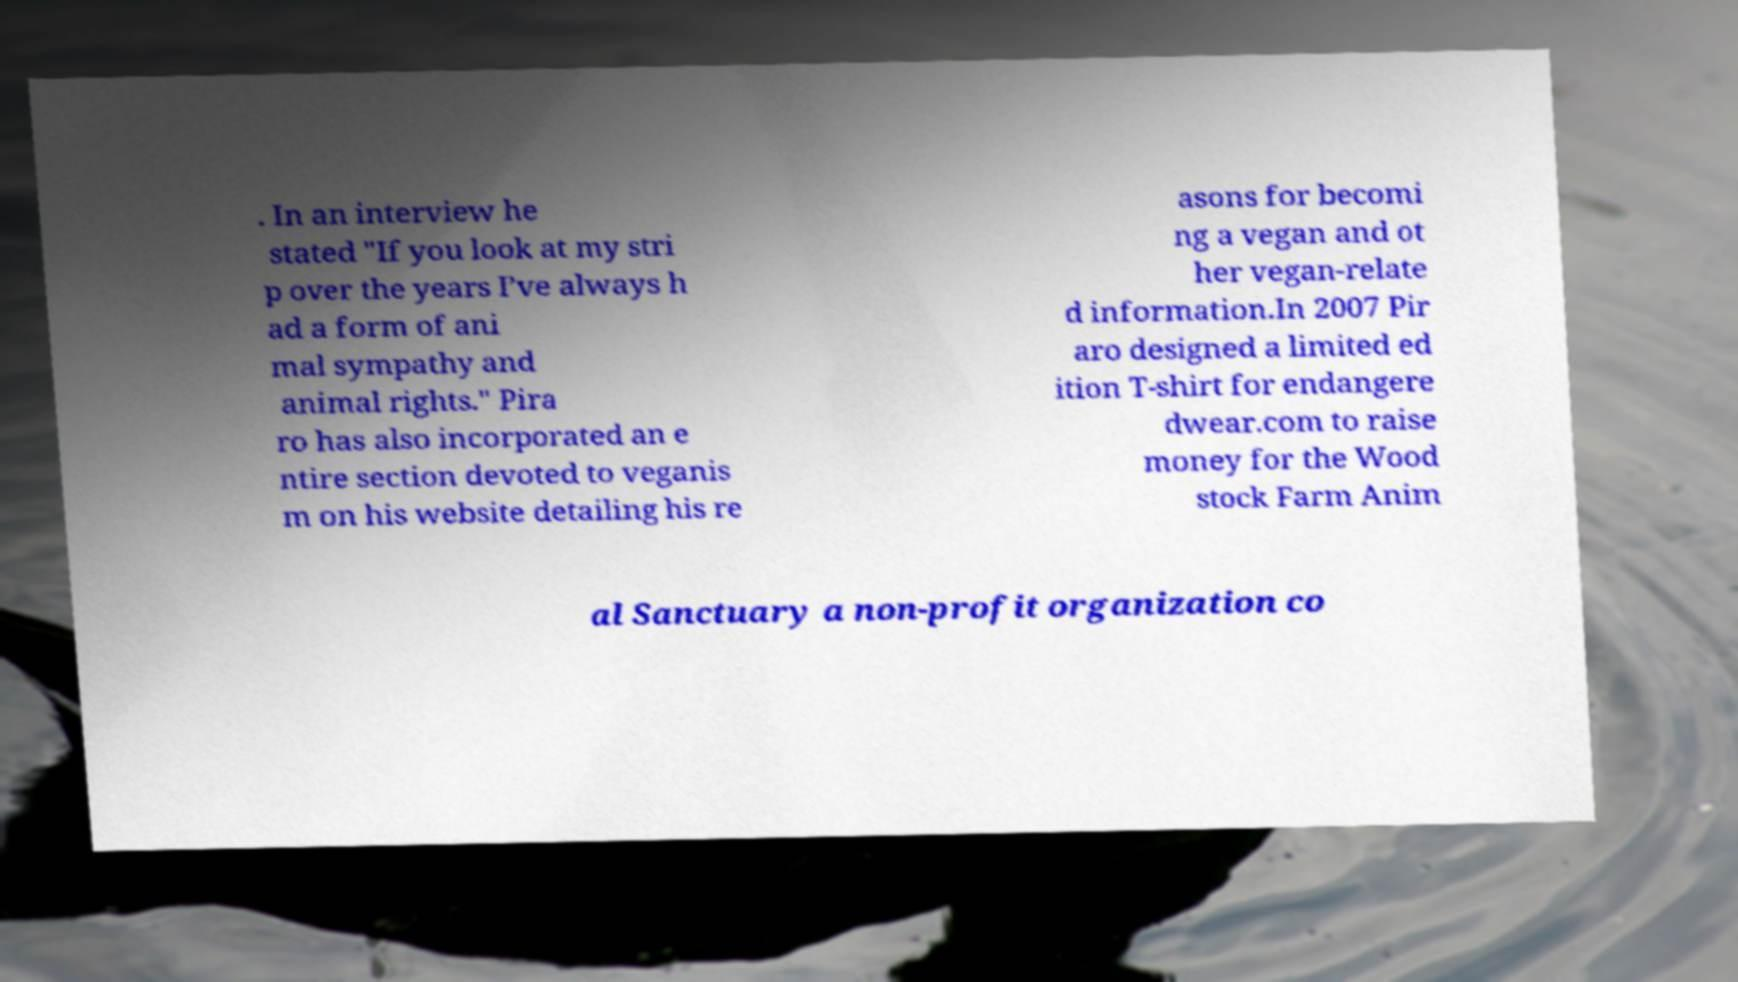Could you extract and type out the text from this image? . In an interview he stated "If you look at my stri p over the years I’ve always h ad a form of ani mal sympathy and animal rights." Pira ro has also incorporated an e ntire section devoted to veganis m on his website detailing his re asons for becomi ng a vegan and ot her vegan-relate d information.In 2007 Pir aro designed a limited ed ition T-shirt for endangere dwear.com to raise money for the Wood stock Farm Anim al Sanctuary a non-profit organization co 